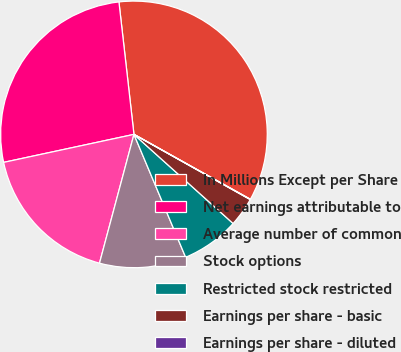<chart> <loc_0><loc_0><loc_500><loc_500><pie_chart><fcel>In Millions Except per Share<fcel>Net earnings attributable to<fcel>Average number of common<fcel>Stock options<fcel>Restricted stock restricted<fcel>Earnings per share - basic<fcel>Earnings per share - diluted<nl><fcel>34.89%<fcel>26.57%<fcel>17.47%<fcel>10.5%<fcel>7.01%<fcel>3.52%<fcel>0.04%<nl></chart> 